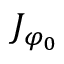Convert formula to latex. <formula><loc_0><loc_0><loc_500><loc_500>J _ { \varphi _ { 0 } }</formula> 